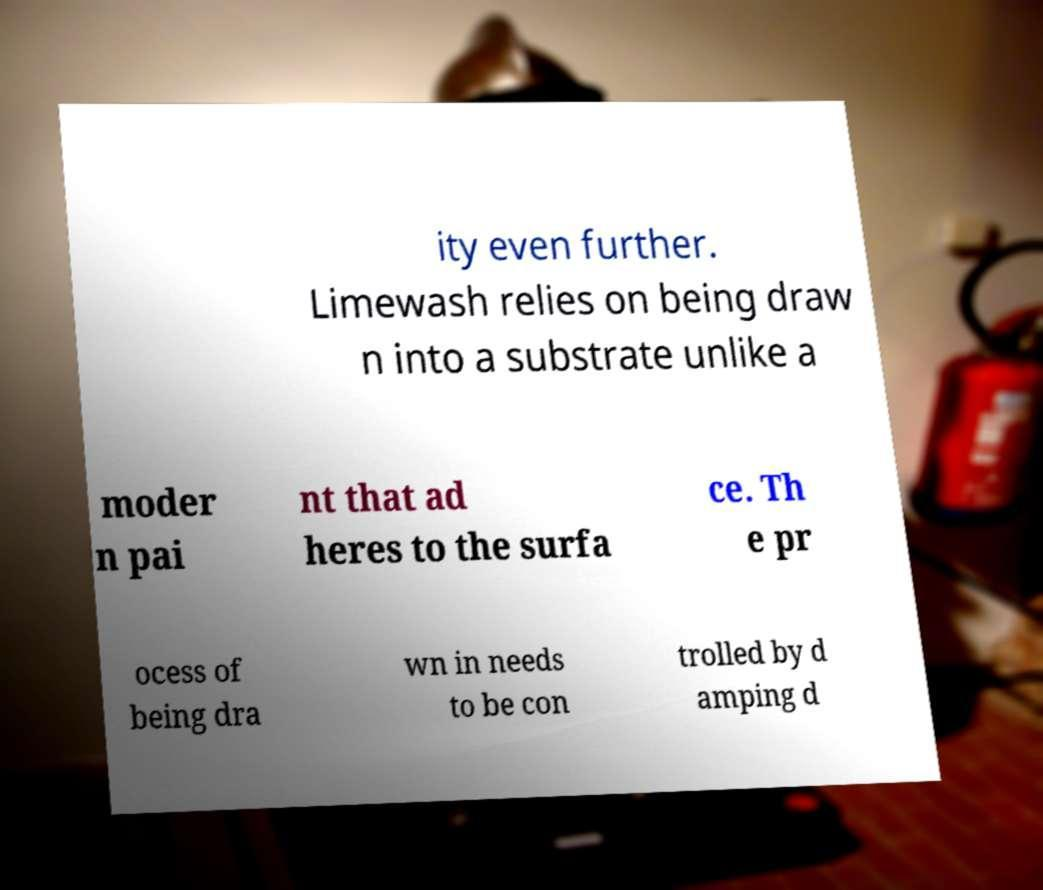Can you accurately transcribe the text from the provided image for me? ity even further. Limewash relies on being draw n into a substrate unlike a moder n pai nt that ad heres to the surfa ce. Th e pr ocess of being dra wn in needs to be con trolled by d amping d 